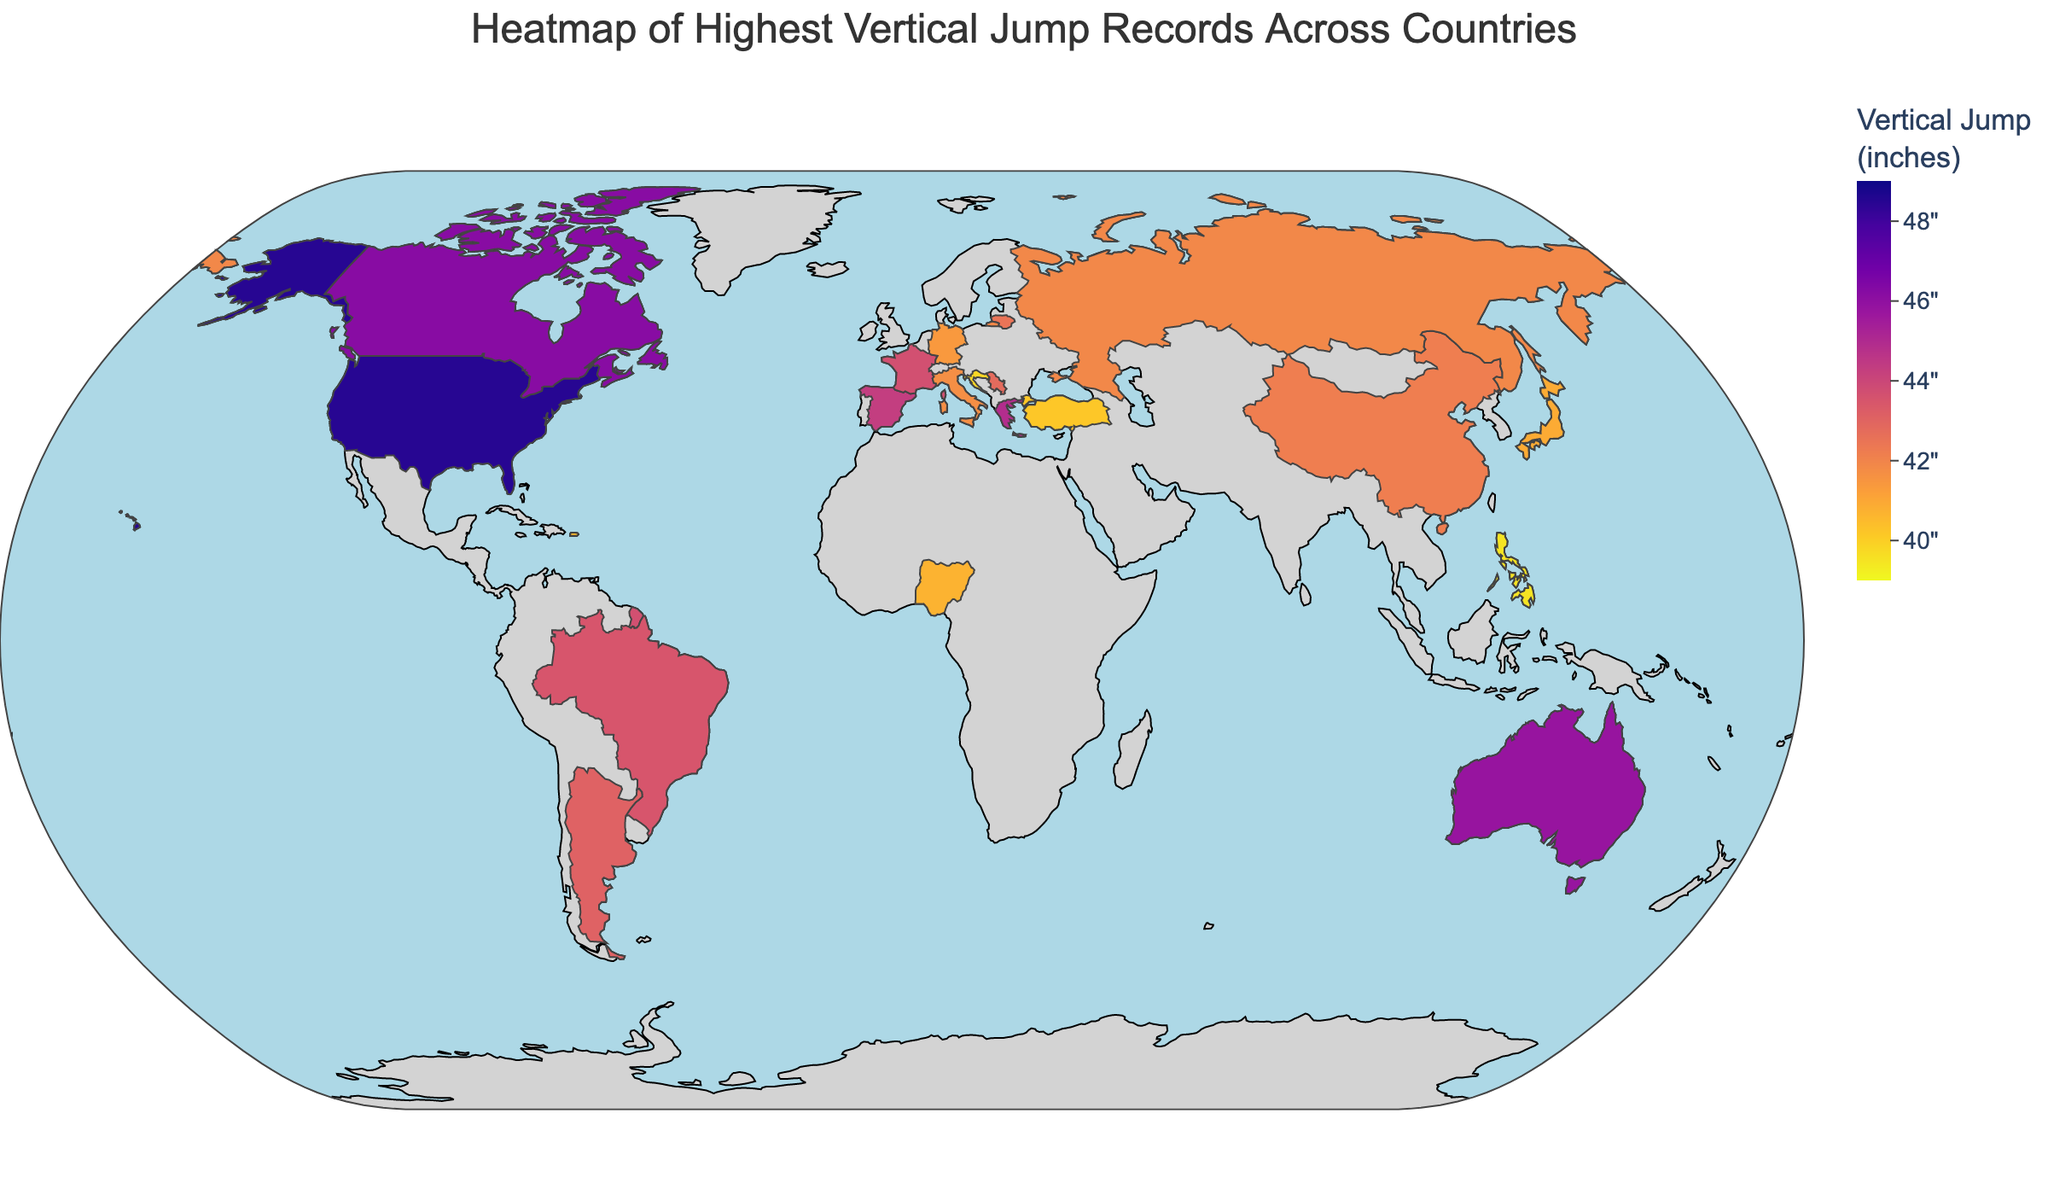What is the title of the map? The title is usually found at the top of the map in a larger font size. It provides a summary of what the map displays.
Answer: Heatmap of Highest Vertical Jump Records Across Countries Which country holds the record for the highest vertical jump? To find this, identify the country with the darkest hue on the color scale indicating the highest value in inches. Based on the data, USA has the highest vertical jump.
Answer: USA How much higher is the highest vertical jump in the USA compared to Serbia? Identify the vertical jump values for the USA and Serbia from the map, then subtract the value for Serbia from that of the USA. The USA has 48.5 inches and Serbia has 42.8 inches. Thus, the difference is 48.5 - 42.8.
Answer: 5.7 inches Which country has the lowest recorded vertical jump, and what is the value? Look for the country with the lightest hue on the map, representing the smallest value. According to the data, the Philippines has the lowest value.
Answer: Philippines, 39.5 inches List all the countries with a vertical jump record of 43 inches or higher. Examine the color scale to identify countries with a hue corresponding to 43 inches or higher. The data provide exact values for verification. The countries are USA, Canada, Australia, Greece, Spain, France, Brazil, and Argentina.
Answer: USA, Canada, Australia, Greece, Spain, France, Brazil, Argentina What is the average vertical jump record of countries with values above 44 inches? Identify countries with vertical jump records above 44 inches, then find the average of these values. The countries are USA (48.5), Canada (46.2), Australia (45.8), and Greece (44.9). The average is (48.5 + 46.2 + 45.8 + 44.9) / 4.
Answer: 46.35 inches Which country in Europe has the highest vertical jump record? Focus on European countries shown on the map and compare their vertical jump values. According to the data, Greece has the highest vertical jump in Europe.
Answer: Greece How many countries have a vertical jump record below 42 inches? Count the countries listed in the data that have a value less than 42 inches. These are Russia, Italy, Germany, Japan, Nigeria, Puerto Rico, Turkey, Croatia, and the Philippines, making a total of 9 countries.
Answer: 9 countries What is the vertical jump record for France? Locate France on the map and refer to the value provided, which can also be verified in the data.
Answer: 43.7 inches 